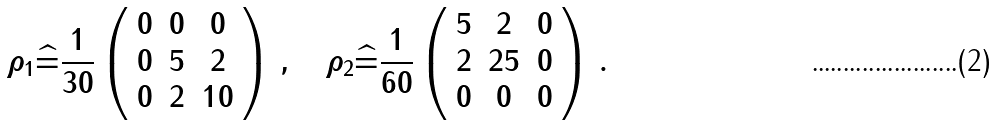<formula> <loc_0><loc_0><loc_500><loc_500>\rho _ { 1 } \widehat { = } \frac { 1 } { 3 0 } \left ( \begin{array} { c c c } 0 & 0 & 0 \\ 0 & 5 & 2 \\ 0 & 2 & 1 0 \end{array} \right ) \, , \quad \rho _ { 2 } \widehat { = } \frac { 1 } { 6 0 } \left ( \begin{array} { c c c } 5 & 2 & 0 \\ 2 & 2 5 & 0 \\ 0 & 0 & 0 \end{array} \right ) \, .</formula> 